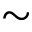Convert formula to latex. <formula><loc_0><loc_0><loc_500><loc_500>\sim</formula> 